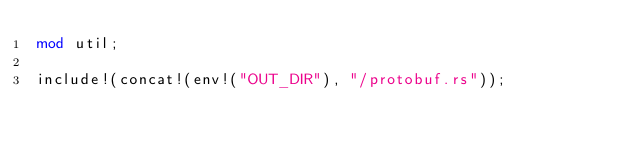Convert code to text. <code><loc_0><loc_0><loc_500><loc_500><_Rust_>mod util;

include!(concat!(env!("OUT_DIR"), "/protobuf.rs"));
</code> 